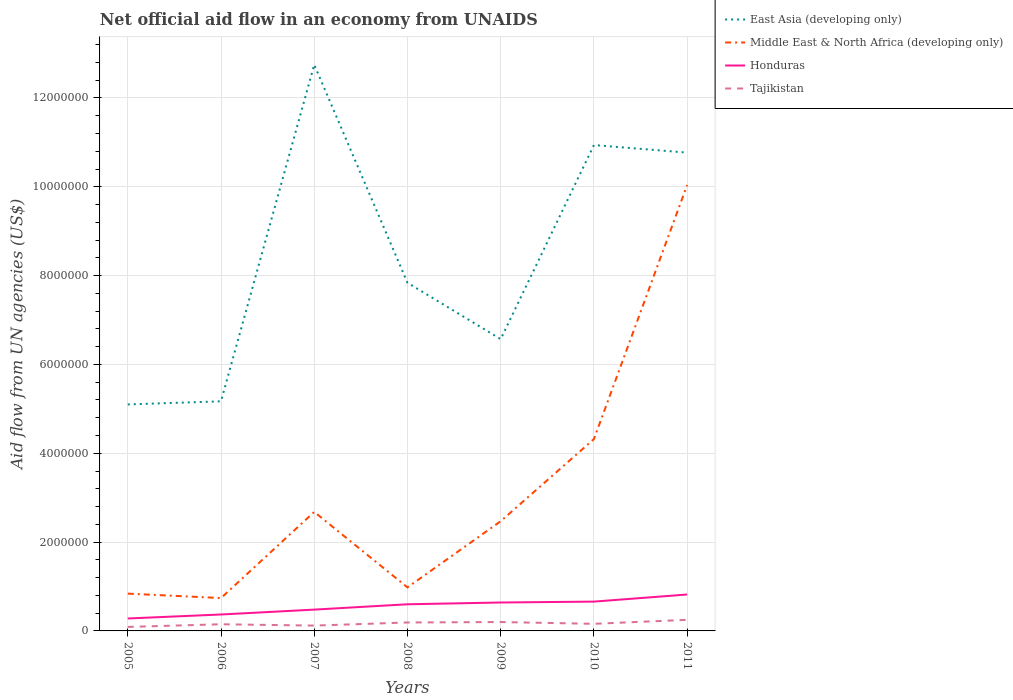How many different coloured lines are there?
Give a very brief answer. 4. Does the line corresponding to Honduras intersect with the line corresponding to Tajikistan?
Your answer should be very brief. No. Across all years, what is the maximum net official aid flow in Middle East & North Africa (developing only)?
Your answer should be compact. 7.40e+05. In which year was the net official aid flow in Tajikistan maximum?
Provide a succinct answer. 2005. What is the total net official aid flow in East Asia (developing only) in the graph?
Make the answer very short. -7.58e+06. What is the difference between the highest and the second highest net official aid flow in Tajikistan?
Offer a terse response. 1.60e+05. Is the net official aid flow in East Asia (developing only) strictly greater than the net official aid flow in Honduras over the years?
Offer a terse response. No. How many lines are there?
Your answer should be very brief. 4. Does the graph contain any zero values?
Make the answer very short. No. Does the graph contain grids?
Offer a very short reply. Yes. How many legend labels are there?
Your answer should be very brief. 4. What is the title of the graph?
Provide a short and direct response. Net official aid flow in an economy from UNAIDS. Does "Algeria" appear as one of the legend labels in the graph?
Offer a terse response. No. What is the label or title of the Y-axis?
Provide a succinct answer. Aid flow from UN agencies (US$). What is the Aid flow from UN agencies (US$) in East Asia (developing only) in 2005?
Ensure brevity in your answer.  5.10e+06. What is the Aid flow from UN agencies (US$) in Middle East & North Africa (developing only) in 2005?
Offer a very short reply. 8.40e+05. What is the Aid flow from UN agencies (US$) in Tajikistan in 2005?
Your response must be concise. 9.00e+04. What is the Aid flow from UN agencies (US$) of East Asia (developing only) in 2006?
Provide a succinct answer. 5.17e+06. What is the Aid flow from UN agencies (US$) of Middle East & North Africa (developing only) in 2006?
Give a very brief answer. 7.40e+05. What is the Aid flow from UN agencies (US$) of Honduras in 2006?
Offer a terse response. 3.70e+05. What is the Aid flow from UN agencies (US$) in Tajikistan in 2006?
Make the answer very short. 1.50e+05. What is the Aid flow from UN agencies (US$) of East Asia (developing only) in 2007?
Ensure brevity in your answer.  1.28e+07. What is the Aid flow from UN agencies (US$) in Middle East & North Africa (developing only) in 2007?
Give a very brief answer. 2.68e+06. What is the Aid flow from UN agencies (US$) of East Asia (developing only) in 2008?
Keep it short and to the point. 7.84e+06. What is the Aid flow from UN agencies (US$) of Middle East & North Africa (developing only) in 2008?
Give a very brief answer. 9.80e+05. What is the Aid flow from UN agencies (US$) in Tajikistan in 2008?
Offer a terse response. 1.90e+05. What is the Aid flow from UN agencies (US$) in East Asia (developing only) in 2009?
Keep it short and to the point. 6.57e+06. What is the Aid flow from UN agencies (US$) in Middle East & North Africa (developing only) in 2009?
Your answer should be very brief. 2.47e+06. What is the Aid flow from UN agencies (US$) in Honduras in 2009?
Provide a short and direct response. 6.40e+05. What is the Aid flow from UN agencies (US$) of East Asia (developing only) in 2010?
Keep it short and to the point. 1.09e+07. What is the Aid flow from UN agencies (US$) in Middle East & North Africa (developing only) in 2010?
Your response must be concise. 4.32e+06. What is the Aid flow from UN agencies (US$) in East Asia (developing only) in 2011?
Provide a short and direct response. 1.08e+07. What is the Aid flow from UN agencies (US$) of Middle East & North Africa (developing only) in 2011?
Your answer should be very brief. 1.00e+07. What is the Aid flow from UN agencies (US$) of Honduras in 2011?
Your answer should be very brief. 8.20e+05. What is the Aid flow from UN agencies (US$) of Tajikistan in 2011?
Offer a terse response. 2.50e+05. Across all years, what is the maximum Aid flow from UN agencies (US$) of East Asia (developing only)?
Your response must be concise. 1.28e+07. Across all years, what is the maximum Aid flow from UN agencies (US$) of Middle East & North Africa (developing only)?
Offer a very short reply. 1.00e+07. Across all years, what is the maximum Aid flow from UN agencies (US$) of Honduras?
Provide a short and direct response. 8.20e+05. Across all years, what is the minimum Aid flow from UN agencies (US$) in East Asia (developing only)?
Ensure brevity in your answer.  5.10e+06. Across all years, what is the minimum Aid flow from UN agencies (US$) in Middle East & North Africa (developing only)?
Your answer should be compact. 7.40e+05. Across all years, what is the minimum Aid flow from UN agencies (US$) in Honduras?
Provide a succinct answer. 2.80e+05. Across all years, what is the minimum Aid flow from UN agencies (US$) of Tajikistan?
Your answer should be very brief. 9.00e+04. What is the total Aid flow from UN agencies (US$) in East Asia (developing only) in the graph?
Provide a short and direct response. 5.91e+07. What is the total Aid flow from UN agencies (US$) of Middle East & North Africa (developing only) in the graph?
Ensure brevity in your answer.  2.21e+07. What is the total Aid flow from UN agencies (US$) in Honduras in the graph?
Your response must be concise. 3.85e+06. What is the total Aid flow from UN agencies (US$) in Tajikistan in the graph?
Ensure brevity in your answer.  1.16e+06. What is the difference between the Aid flow from UN agencies (US$) in Middle East & North Africa (developing only) in 2005 and that in 2006?
Your response must be concise. 1.00e+05. What is the difference between the Aid flow from UN agencies (US$) in East Asia (developing only) in 2005 and that in 2007?
Ensure brevity in your answer.  -7.65e+06. What is the difference between the Aid flow from UN agencies (US$) in Middle East & North Africa (developing only) in 2005 and that in 2007?
Your answer should be very brief. -1.84e+06. What is the difference between the Aid flow from UN agencies (US$) in Honduras in 2005 and that in 2007?
Offer a very short reply. -2.00e+05. What is the difference between the Aid flow from UN agencies (US$) of East Asia (developing only) in 2005 and that in 2008?
Make the answer very short. -2.74e+06. What is the difference between the Aid flow from UN agencies (US$) of Honduras in 2005 and that in 2008?
Provide a succinct answer. -3.20e+05. What is the difference between the Aid flow from UN agencies (US$) of Tajikistan in 2005 and that in 2008?
Offer a terse response. -1.00e+05. What is the difference between the Aid flow from UN agencies (US$) in East Asia (developing only) in 2005 and that in 2009?
Provide a short and direct response. -1.47e+06. What is the difference between the Aid flow from UN agencies (US$) of Middle East & North Africa (developing only) in 2005 and that in 2009?
Provide a succinct answer. -1.63e+06. What is the difference between the Aid flow from UN agencies (US$) of Honduras in 2005 and that in 2009?
Your response must be concise. -3.60e+05. What is the difference between the Aid flow from UN agencies (US$) in East Asia (developing only) in 2005 and that in 2010?
Ensure brevity in your answer.  -5.84e+06. What is the difference between the Aid flow from UN agencies (US$) in Middle East & North Africa (developing only) in 2005 and that in 2010?
Your response must be concise. -3.48e+06. What is the difference between the Aid flow from UN agencies (US$) of Honduras in 2005 and that in 2010?
Provide a succinct answer. -3.80e+05. What is the difference between the Aid flow from UN agencies (US$) of East Asia (developing only) in 2005 and that in 2011?
Your response must be concise. -5.67e+06. What is the difference between the Aid flow from UN agencies (US$) of Middle East & North Africa (developing only) in 2005 and that in 2011?
Keep it short and to the point. -9.20e+06. What is the difference between the Aid flow from UN agencies (US$) in Honduras in 2005 and that in 2011?
Ensure brevity in your answer.  -5.40e+05. What is the difference between the Aid flow from UN agencies (US$) in East Asia (developing only) in 2006 and that in 2007?
Offer a very short reply. -7.58e+06. What is the difference between the Aid flow from UN agencies (US$) in Middle East & North Africa (developing only) in 2006 and that in 2007?
Make the answer very short. -1.94e+06. What is the difference between the Aid flow from UN agencies (US$) in East Asia (developing only) in 2006 and that in 2008?
Offer a very short reply. -2.67e+06. What is the difference between the Aid flow from UN agencies (US$) in Middle East & North Africa (developing only) in 2006 and that in 2008?
Offer a very short reply. -2.40e+05. What is the difference between the Aid flow from UN agencies (US$) of Honduras in 2006 and that in 2008?
Offer a very short reply. -2.30e+05. What is the difference between the Aid flow from UN agencies (US$) in East Asia (developing only) in 2006 and that in 2009?
Ensure brevity in your answer.  -1.40e+06. What is the difference between the Aid flow from UN agencies (US$) of Middle East & North Africa (developing only) in 2006 and that in 2009?
Offer a very short reply. -1.73e+06. What is the difference between the Aid flow from UN agencies (US$) in Honduras in 2006 and that in 2009?
Offer a very short reply. -2.70e+05. What is the difference between the Aid flow from UN agencies (US$) of East Asia (developing only) in 2006 and that in 2010?
Offer a very short reply. -5.77e+06. What is the difference between the Aid flow from UN agencies (US$) of Middle East & North Africa (developing only) in 2006 and that in 2010?
Your response must be concise. -3.58e+06. What is the difference between the Aid flow from UN agencies (US$) of Honduras in 2006 and that in 2010?
Provide a succinct answer. -2.90e+05. What is the difference between the Aid flow from UN agencies (US$) in Tajikistan in 2006 and that in 2010?
Make the answer very short. -10000. What is the difference between the Aid flow from UN agencies (US$) in East Asia (developing only) in 2006 and that in 2011?
Your answer should be compact. -5.60e+06. What is the difference between the Aid flow from UN agencies (US$) of Middle East & North Africa (developing only) in 2006 and that in 2011?
Your answer should be very brief. -9.30e+06. What is the difference between the Aid flow from UN agencies (US$) in Honduras in 2006 and that in 2011?
Ensure brevity in your answer.  -4.50e+05. What is the difference between the Aid flow from UN agencies (US$) of East Asia (developing only) in 2007 and that in 2008?
Keep it short and to the point. 4.91e+06. What is the difference between the Aid flow from UN agencies (US$) in Middle East & North Africa (developing only) in 2007 and that in 2008?
Your answer should be compact. 1.70e+06. What is the difference between the Aid flow from UN agencies (US$) of Honduras in 2007 and that in 2008?
Keep it short and to the point. -1.20e+05. What is the difference between the Aid flow from UN agencies (US$) of East Asia (developing only) in 2007 and that in 2009?
Provide a short and direct response. 6.18e+06. What is the difference between the Aid flow from UN agencies (US$) of Tajikistan in 2007 and that in 2009?
Ensure brevity in your answer.  -8.00e+04. What is the difference between the Aid flow from UN agencies (US$) of East Asia (developing only) in 2007 and that in 2010?
Provide a short and direct response. 1.81e+06. What is the difference between the Aid flow from UN agencies (US$) in Middle East & North Africa (developing only) in 2007 and that in 2010?
Make the answer very short. -1.64e+06. What is the difference between the Aid flow from UN agencies (US$) in East Asia (developing only) in 2007 and that in 2011?
Keep it short and to the point. 1.98e+06. What is the difference between the Aid flow from UN agencies (US$) of Middle East & North Africa (developing only) in 2007 and that in 2011?
Give a very brief answer. -7.36e+06. What is the difference between the Aid flow from UN agencies (US$) in Honduras in 2007 and that in 2011?
Offer a very short reply. -3.40e+05. What is the difference between the Aid flow from UN agencies (US$) in Tajikistan in 2007 and that in 2011?
Your answer should be very brief. -1.30e+05. What is the difference between the Aid flow from UN agencies (US$) in East Asia (developing only) in 2008 and that in 2009?
Offer a terse response. 1.27e+06. What is the difference between the Aid flow from UN agencies (US$) of Middle East & North Africa (developing only) in 2008 and that in 2009?
Provide a succinct answer. -1.49e+06. What is the difference between the Aid flow from UN agencies (US$) of Tajikistan in 2008 and that in 2009?
Offer a very short reply. -10000. What is the difference between the Aid flow from UN agencies (US$) of East Asia (developing only) in 2008 and that in 2010?
Keep it short and to the point. -3.10e+06. What is the difference between the Aid flow from UN agencies (US$) of Middle East & North Africa (developing only) in 2008 and that in 2010?
Keep it short and to the point. -3.34e+06. What is the difference between the Aid flow from UN agencies (US$) of Honduras in 2008 and that in 2010?
Provide a succinct answer. -6.00e+04. What is the difference between the Aid flow from UN agencies (US$) in Tajikistan in 2008 and that in 2010?
Provide a succinct answer. 3.00e+04. What is the difference between the Aid flow from UN agencies (US$) of East Asia (developing only) in 2008 and that in 2011?
Your answer should be compact. -2.93e+06. What is the difference between the Aid flow from UN agencies (US$) of Middle East & North Africa (developing only) in 2008 and that in 2011?
Offer a terse response. -9.06e+06. What is the difference between the Aid flow from UN agencies (US$) of East Asia (developing only) in 2009 and that in 2010?
Ensure brevity in your answer.  -4.37e+06. What is the difference between the Aid flow from UN agencies (US$) of Middle East & North Africa (developing only) in 2009 and that in 2010?
Offer a very short reply. -1.85e+06. What is the difference between the Aid flow from UN agencies (US$) of East Asia (developing only) in 2009 and that in 2011?
Your response must be concise. -4.20e+06. What is the difference between the Aid flow from UN agencies (US$) of Middle East & North Africa (developing only) in 2009 and that in 2011?
Ensure brevity in your answer.  -7.57e+06. What is the difference between the Aid flow from UN agencies (US$) of Tajikistan in 2009 and that in 2011?
Keep it short and to the point. -5.00e+04. What is the difference between the Aid flow from UN agencies (US$) in Middle East & North Africa (developing only) in 2010 and that in 2011?
Give a very brief answer. -5.72e+06. What is the difference between the Aid flow from UN agencies (US$) of Honduras in 2010 and that in 2011?
Keep it short and to the point. -1.60e+05. What is the difference between the Aid flow from UN agencies (US$) of Tajikistan in 2010 and that in 2011?
Give a very brief answer. -9.00e+04. What is the difference between the Aid flow from UN agencies (US$) in East Asia (developing only) in 2005 and the Aid flow from UN agencies (US$) in Middle East & North Africa (developing only) in 2006?
Make the answer very short. 4.36e+06. What is the difference between the Aid flow from UN agencies (US$) of East Asia (developing only) in 2005 and the Aid flow from UN agencies (US$) of Honduras in 2006?
Offer a terse response. 4.73e+06. What is the difference between the Aid flow from UN agencies (US$) in East Asia (developing only) in 2005 and the Aid flow from UN agencies (US$) in Tajikistan in 2006?
Ensure brevity in your answer.  4.95e+06. What is the difference between the Aid flow from UN agencies (US$) of Middle East & North Africa (developing only) in 2005 and the Aid flow from UN agencies (US$) of Honduras in 2006?
Your answer should be compact. 4.70e+05. What is the difference between the Aid flow from UN agencies (US$) in Middle East & North Africa (developing only) in 2005 and the Aid flow from UN agencies (US$) in Tajikistan in 2006?
Provide a succinct answer. 6.90e+05. What is the difference between the Aid flow from UN agencies (US$) of East Asia (developing only) in 2005 and the Aid flow from UN agencies (US$) of Middle East & North Africa (developing only) in 2007?
Provide a succinct answer. 2.42e+06. What is the difference between the Aid flow from UN agencies (US$) of East Asia (developing only) in 2005 and the Aid flow from UN agencies (US$) of Honduras in 2007?
Provide a succinct answer. 4.62e+06. What is the difference between the Aid flow from UN agencies (US$) in East Asia (developing only) in 2005 and the Aid flow from UN agencies (US$) in Tajikistan in 2007?
Provide a short and direct response. 4.98e+06. What is the difference between the Aid flow from UN agencies (US$) in Middle East & North Africa (developing only) in 2005 and the Aid flow from UN agencies (US$) in Honduras in 2007?
Keep it short and to the point. 3.60e+05. What is the difference between the Aid flow from UN agencies (US$) in Middle East & North Africa (developing only) in 2005 and the Aid flow from UN agencies (US$) in Tajikistan in 2007?
Your answer should be compact. 7.20e+05. What is the difference between the Aid flow from UN agencies (US$) in East Asia (developing only) in 2005 and the Aid flow from UN agencies (US$) in Middle East & North Africa (developing only) in 2008?
Provide a succinct answer. 4.12e+06. What is the difference between the Aid flow from UN agencies (US$) in East Asia (developing only) in 2005 and the Aid flow from UN agencies (US$) in Honduras in 2008?
Give a very brief answer. 4.50e+06. What is the difference between the Aid flow from UN agencies (US$) of East Asia (developing only) in 2005 and the Aid flow from UN agencies (US$) of Tajikistan in 2008?
Offer a terse response. 4.91e+06. What is the difference between the Aid flow from UN agencies (US$) in Middle East & North Africa (developing only) in 2005 and the Aid flow from UN agencies (US$) in Tajikistan in 2008?
Keep it short and to the point. 6.50e+05. What is the difference between the Aid flow from UN agencies (US$) of Honduras in 2005 and the Aid flow from UN agencies (US$) of Tajikistan in 2008?
Your response must be concise. 9.00e+04. What is the difference between the Aid flow from UN agencies (US$) in East Asia (developing only) in 2005 and the Aid flow from UN agencies (US$) in Middle East & North Africa (developing only) in 2009?
Give a very brief answer. 2.63e+06. What is the difference between the Aid flow from UN agencies (US$) of East Asia (developing only) in 2005 and the Aid flow from UN agencies (US$) of Honduras in 2009?
Make the answer very short. 4.46e+06. What is the difference between the Aid flow from UN agencies (US$) of East Asia (developing only) in 2005 and the Aid flow from UN agencies (US$) of Tajikistan in 2009?
Provide a short and direct response. 4.90e+06. What is the difference between the Aid flow from UN agencies (US$) of Middle East & North Africa (developing only) in 2005 and the Aid flow from UN agencies (US$) of Honduras in 2009?
Keep it short and to the point. 2.00e+05. What is the difference between the Aid flow from UN agencies (US$) in Middle East & North Africa (developing only) in 2005 and the Aid flow from UN agencies (US$) in Tajikistan in 2009?
Ensure brevity in your answer.  6.40e+05. What is the difference between the Aid flow from UN agencies (US$) in East Asia (developing only) in 2005 and the Aid flow from UN agencies (US$) in Middle East & North Africa (developing only) in 2010?
Provide a succinct answer. 7.80e+05. What is the difference between the Aid flow from UN agencies (US$) in East Asia (developing only) in 2005 and the Aid flow from UN agencies (US$) in Honduras in 2010?
Your answer should be compact. 4.44e+06. What is the difference between the Aid flow from UN agencies (US$) in East Asia (developing only) in 2005 and the Aid flow from UN agencies (US$) in Tajikistan in 2010?
Provide a short and direct response. 4.94e+06. What is the difference between the Aid flow from UN agencies (US$) of Middle East & North Africa (developing only) in 2005 and the Aid flow from UN agencies (US$) of Honduras in 2010?
Keep it short and to the point. 1.80e+05. What is the difference between the Aid flow from UN agencies (US$) in Middle East & North Africa (developing only) in 2005 and the Aid flow from UN agencies (US$) in Tajikistan in 2010?
Your response must be concise. 6.80e+05. What is the difference between the Aid flow from UN agencies (US$) of East Asia (developing only) in 2005 and the Aid flow from UN agencies (US$) of Middle East & North Africa (developing only) in 2011?
Make the answer very short. -4.94e+06. What is the difference between the Aid flow from UN agencies (US$) of East Asia (developing only) in 2005 and the Aid flow from UN agencies (US$) of Honduras in 2011?
Ensure brevity in your answer.  4.28e+06. What is the difference between the Aid flow from UN agencies (US$) in East Asia (developing only) in 2005 and the Aid flow from UN agencies (US$) in Tajikistan in 2011?
Ensure brevity in your answer.  4.85e+06. What is the difference between the Aid flow from UN agencies (US$) in Middle East & North Africa (developing only) in 2005 and the Aid flow from UN agencies (US$) in Tajikistan in 2011?
Your answer should be very brief. 5.90e+05. What is the difference between the Aid flow from UN agencies (US$) in East Asia (developing only) in 2006 and the Aid flow from UN agencies (US$) in Middle East & North Africa (developing only) in 2007?
Provide a succinct answer. 2.49e+06. What is the difference between the Aid flow from UN agencies (US$) in East Asia (developing only) in 2006 and the Aid flow from UN agencies (US$) in Honduras in 2007?
Provide a succinct answer. 4.69e+06. What is the difference between the Aid flow from UN agencies (US$) in East Asia (developing only) in 2006 and the Aid flow from UN agencies (US$) in Tajikistan in 2007?
Provide a short and direct response. 5.05e+06. What is the difference between the Aid flow from UN agencies (US$) of Middle East & North Africa (developing only) in 2006 and the Aid flow from UN agencies (US$) of Honduras in 2007?
Keep it short and to the point. 2.60e+05. What is the difference between the Aid flow from UN agencies (US$) in Middle East & North Africa (developing only) in 2006 and the Aid flow from UN agencies (US$) in Tajikistan in 2007?
Offer a terse response. 6.20e+05. What is the difference between the Aid flow from UN agencies (US$) in East Asia (developing only) in 2006 and the Aid flow from UN agencies (US$) in Middle East & North Africa (developing only) in 2008?
Give a very brief answer. 4.19e+06. What is the difference between the Aid flow from UN agencies (US$) of East Asia (developing only) in 2006 and the Aid flow from UN agencies (US$) of Honduras in 2008?
Offer a terse response. 4.57e+06. What is the difference between the Aid flow from UN agencies (US$) of East Asia (developing only) in 2006 and the Aid flow from UN agencies (US$) of Tajikistan in 2008?
Provide a succinct answer. 4.98e+06. What is the difference between the Aid flow from UN agencies (US$) of East Asia (developing only) in 2006 and the Aid flow from UN agencies (US$) of Middle East & North Africa (developing only) in 2009?
Provide a succinct answer. 2.70e+06. What is the difference between the Aid flow from UN agencies (US$) of East Asia (developing only) in 2006 and the Aid flow from UN agencies (US$) of Honduras in 2009?
Offer a very short reply. 4.53e+06. What is the difference between the Aid flow from UN agencies (US$) of East Asia (developing only) in 2006 and the Aid flow from UN agencies (US$) of Tajikistan in 2009?
Provide a succinct answer. 4.97e+06. What is the difference between the Aid flow from UN agencies (US$) of Middle East & North Africa (developing only) in 2006 and the Aid flow from UN agencies (US$) of Honduras in 2009?
Offer a very short reply. 1.00e+05. What is the difference between the Aid flow from UN agencies (US$) of Middle East & North Africa (developing only) in 2006 and the Aid flow from UN agencies (US$) of Tajikistan in 2009?
Provide a succinct answer. 5.40e+05. What is the difference between the Aid flow from UN agencies (US$) of East Asia (developing only) in 2006 and the Aid flow from UN agencies (US$) of Middle East & North Africa (developing only) in 2010?
Your response must be concise. 8.50e+05. What is the difference between the Aid flow from UN agencies (US$) in East Asia (developing only) in 2006 and the Aid flow from UN agencies (US$) in Honduras in 2010?
Offer a very short reply. 4.51e+06. What is the difference between the Aid flow from UN agencies (US$) in East Asia (developing only) in 2006 and the Aid flow from UN agencies (US$) in Tajikistan in 2010?
Ensure brevity in your answer.  5.01e+06. What is the difference between the Aid flow from UN agencies (US$) in Middle East & North Africa (developing only) in 2006 and the Aid flow from UN agencies (US$) in Tajikistan in 2010?
Provide a short and direct response. 5.80e+05. What is the difference between the Aid flow from UN agencies (US$) of Honduras in 2006 and the Aid flow from UN agencies (US$) of Tajikistan in 2010?
Keep it short and to the point. 2.10e+05. What is the difference between the Aid flow from UN agencies (US$) in East Asia (developing only) in 2006 and the Aid flow from UN agencies (US$) in Middle East & North Africa (developing only) in 2011?
Keep it short and to the point. -4.87e+06. What is the difference between the Aid flow from UN agencies (US$) of East Asia (developing only) in 2006 and the Aid flow from UN agencies (US$) of Honduras in 2011?
Your response must be concise. 4.35e+06. What is the difference between the Aid flow from UN agencies (US$) in East Asia (developing only) in 2006 and the Aid flow from UN agencies (US$) in Tajikistan in 2011?
Provide a succinct answer. 4.92e+06. What is the difference between the Aid flow from UN agencies (US$) of Middle East & North Africa (developing only) in 2006 and the Aid flow from UN agencies (US$) of Tajikistan in 2011?
Ensure brevity in your answer.  4.90e+05. What is the difference between the Aid flow from UN agencies (US$) in East Asia (developing only) in 2007 and the Aid flow from UN agencies (US$) in Middle East & North Africa (developing only) in 2008?
Make the answer very short. 1.18e+07. What is the difference between the Aid flow from UN agencies (US$) of East Asia (developing only) in 2007 and the Aid flow from UN agencies (US$) of Honduras in 2008?
Give a very brief answer. 1.22e+07. What is the difference between the Aid flow from UN agencies (US$) in East Asia (developing only) in 2007 and the Aid flow from UN agencies (US$) in Tajikistan in 2008?
Offer a terse response. 1.26e+07. What is the difference between the Aid flow from UN agencies (US$) of Middle East & North Africa (developing only) in 2007 and the Aid flow from UN agencies (US$) of Honduras in 2008?
Make the answer very short. 2.08e+06. What is the difference between the Aid flow from UN agencies (US$) of Middle East & North Africa (developing only) in 2007 and the Aid flow from UN agencies (US$) of Tajikistan in 2008?
Keep it short and to the point. 2.49e+06. What is the difference between the Aid flow from UN agencies (US$) of East Asia (developing only) in 2007 and the Aid flow from UN agencies (US$) of Middle East & North Africa (developing only) in 2009?
Provide a succinct answer. 1.03e+07. What is the difference between the Aid flow from UN agencies (US$) in East Asia (developing only) in 2007 and the Aid flow from UN agencies (US$) in Honduras in 2009?
Offer a very short reply. 1.21e+07. What is the difference between the Aid flow from UN agencies (US$) of East Asia (developing only) in 2007 and the Aid flow from UN agencies (US$) of Tajikistan in 2009?
Ensure brevity in your answer.  1.26e+07. What is the difference between the Aid flow from UN agencies (US$) of Middle East & North Africa (developing only) in 2007 and the Aid flow from UN agencies (US$) of Honduras in 2009?
Offer a very short reply. 2.04e+06. What is the difference between the Aid flow from UN agencies (US$) in Middle East & North Africa (developing only) in 2007 and the Aid flow from UN agencies (US$) in Tajikistan in 2009?
Ensure brevity in your answer.  2.48e+06. What is the difference between the Aid flow from UN agencies (US$) of Honduras in 2007 and the Aid flow from UN agencies (US$) of Tajikistan in 2009?
Provide a short and direct response. 2.80e+05. What is the difference between the Aid flow from UN agencies (US$) in East Asia (developing only) in 2007 and the Aid flow from UN agencies (US$) in Middle East & North Africa (developing only) in 2010?
Provide a short and direct response. 8.43e+06. What is the difference between the Aid flow from UN agencies (US$) in East Asia (developing only) in 2007 and the Aid flow from UN agencies (US$) in Honduras in 2010?
Provide a short and direct response. 1.21e+07. What is the difference between the Aid flow from UN agencies (US$) in East Asia (developing only) in 2007 and the Aid flow from UN agencies (US$) in Tajikistan in 2010?
Your response must be concise. 1.26e+07. What is the difference between the Aid flow from UN agencies (US$) of Middle East & North Africa (developing only) in 2007 and the Aid flow from UN agencies (US$) of Honduras in 2010?
Keep it short and to the point. 2.02e+06. What is the difference between the Aid flow from UN agencies (US$) of Middle East & North Africa (developing only) in 2007 and the Aid flow from UN agencies (US$) of Tajikistan in 2010?
Make the answer very short. 2.52e+06. What is the difference between the Aid flow from UN agencies (US$) of East Asia (developing only) in 2007 and the Aid flow from UN agencies (US$) of Middle East & North Africa (developing only) in 2011?
Make the answer very short. 2.71e+06. What is the difference between the Aid flow from UN agencies (US$) in East Asia (developing only) in 2007 and the Aid flow from UN agencies (US$) in Honduras in 2011?
Provide a short and direct response. 1.19e+07. What is the difference between the Aid flow from UN agencies (US$) of East Asia (developing only) in 2007 and the Aid flow from UN agencies (US$) of Tajikistan in 2011?
Offer a terse response. 1.25e+07. What is the difference between the Aid flow from UN agencies (US$) in Middle East & North Africa (developing only) in 2007 and the Aid flow from UN agencies (US$) in Honduras in 2011?
Provide a succinct answer. 1.86e+06. What is the difference between the Aid flow from UN agencies (US$) of Middle East & North Africa (developing only) in 2007 and the Aid flow from UN agencies (US$) of Tajikistan in 2011?
Offer a terse response. 2.43e+06. What is the difference between the Aid flow from UN agencies (US$) in Honduras in 2007 and the Aid flow from UN agencies (US$) in Tajikistan in 2011?
Ensure brevity in your answer.  2.30e+05. What is the difference between the Aid flow from UN agencies (US$) in East Asia (developing only) in 2008 and the Aid flow from UN agencies (US$) in Middle East & North Africa (developing only) in 2009?
Your response must be concise. 5.37e+06. What is the difference between the Aid flow from UN agencies (US$) in East Asia (developing only) in 2008 and the Aid flow from UN agencies (US$) in Honduras in 2009?
Offer a very short reply. 7.20e+06. What is the difference between the Aid flow from UN agencies (US$) of East Asia (developing only) in 2008 and the Aid flow from UN agencies (US$) of Tajikistan in 2009?
Your answer should be very brief. 7.64e+06. What is the difference between the Aid flow from UN agencies (US$) in Middle East & North Africa (developing only) in 2008 and the Aid flow from UN agencies (US$) in Tajikistan in 2009?
Your answer should be very brief. 7.80e+05. What is the difference between the Aid flow from UN agencies (US$) of East Asia (developing only) in 2008 and the Aid flow from UN agencies (US$) of Middle East & North Africa (developing only) in 2010?
Make the answer very short. 3.52e+06. What is the difference between the Aid flow from UN agencies (US$) in East Asia (developing only) in 2008 and the Aid flow from UN agencies (US$) in Honduras in 2010?
Provide a succinct answer. 7.18e+06. What is the difference between the Aid flow from UN agencies (US$) in East Asia (developing only) in 2008 and the Aid flow from UN agencies (US$) in Tajikistan in 2010?
Your answer should be compact. 7.68e+06. What is the difference between the Aid flow from UN agencies (US$) of Middle East & North Africa (developing only) in 2008 and the Aid flow from UN agencies (US$) of Tajikistan in 2010?
Give a very brief answer. 8.20e+05. What is the difference between the Aid flow from UN agencies (US$) of Honduras in 2008 and the Aid flow from UN agencies (US$) of Tajikistan in 2010?
Your answer should be very brief. 4.40e+05. What is the difference between the Aid flow from UN agencies (US$) in East Asia (developing only) in 2008 and the Aid flow from UN agencies (US$) in Middle East & North Africa (developing only) in 2011?
Provide a succinct answer. -2.20e+06. What is the difference between the Aid flow from UN agencies (US$) in East Asia (developing only) in 2008 and the Aid flow from UN agencies (US$) in Honduras in 2011?
Provide a short and direct response. 7.02e+06. What is the difference between the Aid flow from UN agencies (US$) in East Asia (developing only) in 2008 and the Aid flow from UN agencies (US$) in Tajikistan in 2011?
Your answer should be very brief. 7.59e+06. What is the difference between the Aid flow from UN agencies (US$) of Middle East & North Africa (developing only) in 2008 and the Aid flow from UN agencies (US$) of Tajikistan in 2011?
Offer a terse response. 7.30e+05. What is the difference between the Aid flow from UN agencies (US$) of East Asia (developing only) in 2009 and the Aid flow from UN agencies (US$) of Middle East & North Africa (developing only) in 2010?
Provide a short and direct response. 2.25e+06. What is the difference between the Aid flow from UN agencies (US$) of East Asia (developing only) in 2009 and the Aid flow from UN agencies (US$) of Honduras in 2010?
Offer a very short reply. 5.91e+06. What is the difference between the Aid flow from UN agencies (US$) in East Asia (developing only) in 2009 and the Aid flow from UN agencies (US$) in Tajikistan in 2010?
Make the answer very short. 6.41e+06. What is the difference between the Aid flow from UN agencies (US$) in Middle East & North Africa (developing only) in 2009 and the Aid flow from UN agencies (US$) in Honduras in 2010?
Your response must be concise. 1.81e+06. What is the difference between the Aid flow from UN agencies (US$) of Middle East & North Africa (developing only) in 2009 and the Aid flow from UN agencies (US$) of Tajikistan in 2010?
Your response must be concise. 2.31e+06. What is the difference between the Aid flow from UN agencies (US$) in Honduras in 2009 and the Aid flow from UN agencies (US$) in Tajikistan in 2010?
Provide a short and direct response. 4.80e+05. What is the difference between the Aid flow from UN agencies (US$) of East Asia (developing only) in 2009 and the Aid flow from UN agencies (US$) of Middle East & North Africa (developing only) in 2011?
Provide a short and direct response. -3.47e+06. What is the difference between the Aid flow from UN agencies (US$) in East Asia (developing only) in 2009 and the Aid flow from UN agencies (US$) in Honduras in 2011?
Provide a short and direct response. 5.75e+06. What is the difference between the Aid flow from UN agencies (US$) in East Asia (developing only) in 2009 and the Aid flow from UN agencies (US$) in Tajikistan in 2011?
Provide a succinct answer. 6.32e+06. What is the difference between the Aid flow from UN agencies (US$) of Middle East & North Africa (developing only) in 2009 and the Aid flow from UN agencies (US$) of Honduras in 2011?
Make the answer very short. 1.65e+06. What is the difference between the Aid flow from UN agencies (US$) in Middle East & North Africa (developing only) in 2009 and the Aid flow from UN agencies (US$) in Tajikistan in 2011?
Give a very brief answer. 2.22e+06. What is the difference between the Aid flow from UN agencies (US$) in Honduras in 2009 and the Aid flow from UN agencies (US$) in Tajikistan in 2011?
Provide a succinct answer. 3.90e+05. What is the difference between the Aid flow from UN agencies (US$) in East Asia (developing only) in 2010 and the Aid flow from UN agencies (US$) in Middle East & North Africa (developing only) in 2011?
Make the answer very short. 9.00e+05. What is the difference between the Aid flow from UN agencies (US$) of East Asia (developing only) in 2010 and the Aid flow from UN agencies (US$) of Honduras in 2011?
Keep it short and to the point. 1.01e+07. What is the difference between the Aid flow from UN agencies (US$) in East Asia (developing only) in 2010 and the Aid flow from UN agencies (US$) in Tajikistan in 2011?
Provide a short and direct response. 1.07e+07. What is the difference between the Aid flow from UN agencies (US$) of Middle East & North Africa (developing only) in 2010 and the Aid flow from UN agencies (US$) of Honduras in 2011?
Give a very brief answer. 3.50e+06. What is the difference between the Aid flow from UN agencies (US$) of Middle East & North Africa (developing only) in 2010 and the Aid flow from UN agencies (US$) of Tajikistan in 2011?
Provide a short and direct response. 4.07e+06. What is the average Aid flow from UN agencies (US$) in East Asia (developing only) per year?
Ensure brevity in your answer.  8.45e+06. What is the average Aid flow from UN agencies (US$) in Middle East & North Africa (developing only) per year?
Offer a terse response. 3.15e+06. What is the average Aid flow from UN agencies (US$) in Tajikistan per year?
Make the answer very short. 1.66e+05. In the year 2005, what is the difference between the Aid flow from UN agencies (US$) of East Asia (developing only) and Aid flow from UN agencies (US$) of Middle East & North Africa (developing only)?
Provide a short and direct response. 4.26e+06. In the year 2005, what is the difference between the Aid flow from UN agencies (US$) of East Asia (developing only) and Aid flow from UN agencies (US$) of Honduras?
Ensure brevity in your answer.  4.82e+06. In the year 2005, what is the difference between the Aid flow from UN agencies (US$) in East Asia (developing only) and Aid flow from UN agencies (US$) in Tajikistan?
Your answer should be very brief. 5.01e+06. In the year 2005, what is the difference between the Aid flow from UN agencies (US$) of Middle East & North Africa (developing only) and Aid flow from UN agencies (US$) of Honduras?
Your response must be concise. 5.60e+05. In the year 2005, what is the difference between the Aid flow from UN agencies (US$) in Middle East & North Africa (developing only) and Aid flow from UN agencies (US$) in Tajikistan?
Provide a short and direct response. 7.50e+05. In the year 2006, what is the difference between the Aid flow from UN agencies (US$) of East Asia (developing only) and Aid flow from UN agencies (US$) of Middle East & North Africa (developing only)?
Make the answer very short. 4.43e+06. In the year 2006, what is the difference between the Aid flow from UN agencies (US$) in East Asia (developing only) and Aid flow from UN agencies (US$) in Honduras?
Offer a terse response. 4.80e+06. In the year 2006, what is the difference between the Aid flow from UN agencies (US$) in East Asia (developing only) and Aid flow from UN agencies (US$) in Tajikistan?
Keep it short and to the point. 5.02e+06. In the year 2006, what is the difference between the Aid flow from UN agencies (US$) in Middle East & North Africa (developing only) and Aid flow from UN agencies (US$) in Honduras?
Make the answer very short. 3.70e+05. In the year 2006, what is the difference between the Aid flow from UN agencies (US$) of Middle East & North Africa (developing only) and Aid flow from UN agencies (US$) of Tajikistan?
Offer a very short reply. 5.90e+05. In the year 2006, what is the difference between the Aid flow from UN agencies (US$) in Honduras and Aid flow from UN agencies (US$) in Tajikistan?
Your response must be concise. 2.20e+05. In the year 2007, what is the difference between the Aid flow from UN agencies (US$) in East Asia (developing only) and Aid flow from UN agencies (US$) in Middle East & North Africa (developing only)?
Your response must be concise. 1.01e+07. In the year 2007, what is the difference between the Aid flow from UN agencies (US$) of East Asia (developing only) and Aid flow from UN agencies (US$) of Honduras?
Provide a succinct answer. 1.23e+07. In the year 2007, what is the difference between the Aid flow from UN agencies (US$) in East Asia (developing only) and Aid flow from UN agencies (US$) in Tajikistan?
Provide a succinct answer. 1.26e+07. In the year 2007, what is the difference between the Aid flow from UN agencies (US$) in Middle East & North Africa (developing only) and Aid flow from UN agencies (US$) in Honduras?
Give a very brief answer. 2.20e+06. In the year 2007, what is the difference between the Aid flow from UN agencies (US$) in Middle East & North Africa (developing only) and Aid flow from UN agencies (US$) in Tajikistan?
Your answer should be very brief. 2.56e+06. In the year 2007, what is the difference between the Aid flow from UN agencies (US$) of Honduras and Aid flow from UN agencies (US$) of Tajikistan?
Your answer should be compact. 3.60e+05. In the year 2008, what is the difference between the Aid flow from UN agencies (US$) in East Asia (developing only) and Aid flow from UN agencies (US$) in Middle East & North Africa (developing only)?
Offer a very short reply. 6.86e+06. In the year 2008, what is the difference between the Aid flow from UN agencies (US$) in East Asia (developing only) and Aid flow from UN agencies (US$) in Honduras?
Make the answer very short. 7.24e+06. In the year 2008, what is the difference between the Aid flow from UN agencies (US$) in East Asia (developing only) and Aid flow from UN agencies (US$) in Tajikistan?
Make the answer very short. 7.65e+06. In the year 2008, what is the difference between the Aid flow from UN agencies (US$) in Middle East & North Africa (developing only) and Aid flow from UN agencies (US$) in Tajikistan?
Keep it short and to the point. 7.90e+05. In the year 2008, what is the difference between the Aid flow from UN agencies (US$) in Honduras and Aid flow from UN agencies (US$) in Tajikistan?
Provide a short and direct response. 4.10e+05. In the year 2009, what is the difference between the Aid flow from UN agencies (US$) in East Asia (developing only) and Aid flow from UN agencies (US$) in Middle East & North Africa (developing only)?
Offer a very short reply. 4.10e+06. In the year 2009, what is the difference between the Aid flow from UN agencies (US$) of East Asia (developing only) and Aid flow from UN agencies (US$) of Honduras?
Provide a short and direct response. 5.93e+06. In the year 2009, what is the difference between the Aid flow from UN agencies (US$) of East Asia (developing only) and Aid flow from UN agencies (US$) of Tajikistan?
Your answer should be very brief. 6.37e+06. In the year 2009, what is the difference between the Aid flow from UN agencies (US$) of Middle East & North Africa (developing only) and Aid flow from UN agencies (US$) of Honduras?
Give a very brief answer. 1.83e+06. In the year 2009, what is the difference between the Aid flow from UN agencies (US$) of Middle East & North Africa (developing only) and Aid flow from UN agencies (US$) of Tajikistan?
Your answer should be very brief. 2.27e+06. In the year 2010, what is the difference between the Aid flow from UN agencies (US$) of East Asia (developing only) and Aid flow from UN agencies (US$) of Middle East & North Africa (developing only)?
Give a very brief answer. 6.62e+06. In the year 2010, what is the difference between the Aid flow from UN agencies (US$) of East Asia (developing only) and Aid flow from UN agencies (US$) of Honduras?
Your response must be concise. 1.03e+07. In the year 2010, what is the difference between the Aid flow from UN agencies (US$) in East Asia (developing only) and Aid flow from UN agencies (US$) in Tajikistan?
Keep it short and to the point. 1.08e+07. In the year 2010, what is the difference between the Aid flow from UN agencies (US$) in Middle East & North Africa (developing only) and Aid flow from UN agencies (US$) in Honduras?
Your answer should be very brief. 3.66e+06. In the year 2010, what is the difference between the Aid flow from UN agencies (US$) of Middle East & North Africa (developing only) and Aid flow from UN agencies (US$) of Tajikistan?
Your answer should be compact. 4.16e+06. In the year 2010, what is the difference between the Aid flow from UN agencies (US$) in Honduras and Aid flow from UN agencies (US$) in Tajikistan?
Offer a very short reply. 5.00e+05. In the year 2011, what is the difference between the Aid flow from UN agencies (US$) in East Asia (developing only) and Aid flow from UN agencies (US$) in Middle East & North Africa (developing only)?
Your answer should be compact. 7.30e+05. In the year 2011, what is the difference between the Aid flow from UN agencies (US$) in East Asia (developing only) and Aid flow from UN agencies (US$) in Honduras?
Offer a very short reply. 9.95e+06. In the year 2011, what is the difference between the Aid flow from UN agencies (US$) in East Asia (developing only) and Aid flow from UN agencies (US$) in Tajikistan?
Offer a terse response. 1.05e+07. In the year 2011, what is the difference between the Aid flow from UN agencies (US$) in Middle East & North Africa (developing only) and Aid flow from UN agencies (US$) in Honduras?
Offer a very short reply. 9.22e+06. In the year 2011, what is the difference between the Aid flow from UN agencies (US$) of Middle East & North Africa (developing only) and Aid flow from UN agencies (US$) of Tajikistan?
Your answer should be very brief. 9.79e+06. In the year 2011, what is the difference between the Aid flow from UN agencies (US$) in Honduras and Aid flow from UN agencies (US$) in Tajikistan?
Your answer should be compact. 5.70e+05. What is the ratio of the Aid flow from UN agencies (US$) in East Asia (developing only) in 2005 to that in 2006?
Your response must be concise. 0.99. What is the ratio of the Aid flow from UN agencies (US$) of Middle East & North Africa (developing only) in 2005 to that in 2006?
Keep it short and to the point. 1.14. What is the ratio of the Aid flow from UN agencies (US$) of Honduras in 2005 to that in 2006?
Your answer should be compact. 0.76. What is the ratio of the Aid flow from UN agencies (US$) of Middle East & North Africa (developing only) in 2005 to that in 2007?
Your response must be concise. 0.31. What is the ratio of the Aid flow from UN agencies (US$) in Honduras in 2005 to that in 2007?
Offer a very short reply. 0.58. What is the ratio of the Aid flow from UN agencies (US$) in Tajikistan in 2005 to that in 2007?
Your answer should be compact. 0.75. What is the ratio of the Aid flow from UN agencies (US$) of East Asia (developing only) in 2005 to that in 2008?
Keep it short and to the point. 0.65. What is the ratio of the Aid flow from UN agencies (US$) of Middle East & North Africa (developing only) in 2005 to that in 2008?
Keep it short and to the point. 0.86. What is the ratio of the Aid flow from UN agencies (US$) of Honduras in 2005 to that in 2008?
Provide a short and direct response. 0.47. What is the ratio of the Aid flow from UN agencies (US$) in Tajikistan in 2005 to that in 2008?
Give a very brief answer. 0.47. What is the ratio of the Aid flow from UN agencies (US$) in East Asia (developing only) in 2005 to that in 2009?
Keep it short and to the point. 0.78. What is the ratio of the Aid flow from UN agencies (US$) of Middle East & North Africa (developing only) in 2005 to that in 2009?
Make the answer very short. 0.34. What is the ratio of the Aid flow from UN agencies (US$) in Honduras in 2005 to that in 2009?
Make the answer very short. 0.44. What is the ratio of the Aid flow from UN agencies (US$) of Tajikistan in 2005 to that in 2009?
Offer a terse response. 0.45. What is the ratio of the Aid flow from UN agencies (US$) in East Asia (developing only) in 2005 to that in 2010?
Provide a short and direct response. 0.47. What is the ratio of the Aid flow from UN agencies (US$) in Middle East & North Africa (developing only) in 2005 to that in 2010?
Your answer should be compact. 0.19. What is the ratio of the Aid flow from UN agencies (US$) of Honduras in 2005 to that in 2010?
Give a very brief answer. 0.42. What is the ratio of the Aid flow from UN agencies (US$) in Tajikistan in 2005 to that in 2010?
Provide a succinct answer. 0.56. What is the ratio of the Aid flow from UN agencies (US$) in East Asia (developing only) in 2005 to that in 2011?
Your response must be concise. 0.47. What is the ratio of the Aid flow from UN agencies (US$) in Middle East & North Africa (developing only) in 2005 to that in 2011?
Your answer should be compact. 0.08. What is the ratio of the Aid flow from UN agencies (US$) in Honduras in 2005 to that in 2011?
Your answer should be compact. 0.34. What is the ratio of the Aid flow from UN agencies (US$) in Tajikistan in 2005 to that in 2011?
Provide a short and direct response. 0.36. What is the ratio of the Aid flow from UN agencies (US$) in East Asia (developing only) in 2006 to that in 2007?
Your answer should be very brief. 0.41. What is the ratio of the Aid flow from UN agencies (US$) in Middle East & North Africa (developing only) in 2006 to that in 2007?
Offer a very short reply. 0.28. What is the ratio of the Aid flow from UN agencies (US$) in Honduras in 2006 to that in 2007?
Give a very brief answer. 0.77. What is the ratio of the Aid flow from UN agencies (US$) in East Asia (developing only) in 2006 to that in 2008?
Make the answer very short. 0.66. What is the ratio of the Aid flow from UN agencies (US$) of Middle East & North Africa (developing only) in 2006 to that in 2008?
Offer a very short reply. 0.76. What is the ratio of the Aid flow from UN agencies (US$) in Honduras in 2006 to that in 2008?
Provide a succinct answer. 0.62. What is the ratio of the Aid flow from UN agencies (US$) of Tajikistan in 2006 to that in 2008?
Your response must be concise. 0.79. What is the ratio of the Aid flow from UN agencies (US$) of East Asia (developing only) in 2006 to that in 2009?
Ensure brevity in your answer.  0.79. What is the ratio of the Aid flow from UN agencies (US$) in Middle East & North Africa (developing only) in 2006 to that in 2009?
Offer a terse response. 0.3. What is the ratio of the Aid flow from UN agencies (US$) in Honduras in 2006 to that in 2009?
Provide a succinct answer. 0.58. What is the ratio of the Aid flow from UN agencies (US$) of East Asia (developing only) in 2006 to that in 2010?
Provide a succinct answer. 0.47. What is the ratio of the Aid flow from UN agencies (US$) in Middle East & North Africa (developing only) in 2006 to that in 2010?
Your response must be concise. 0.17. What is the ratio of the Aid flow from UN agencies (US$) of Honduras in 2006 to that in 2010?
Your response must be concise. 0.56. What is the ratio of the Aid flow from UN agencies (US$) in East Asia (developing only) in 2006 to that in 2011?
Provide a short and direct response. 0.48. What is the ratio of the Aid flow from UN agencies (US$) in Middle East & North Africa (developing only) in 2006 to that in 2011?
Your answer should be compact. 0.07. What is the ratio of the Aid flow from UN agencies (US$) of Honduras in 2006 to that in 2011?
Give a very brief answer. 0.45. What is the ratio of the Aid flow from UN agencies (US$) in East Asia (developing only) in 2007 to that in 2008?
Your answer should be very brief. 1.63. What is the ratio of the Aid flow from UN agencies (US$) in Middle East & North Africa (developing only) in 2007 to that in 2008?
Offer a terse response. 2.73. What is the ratio of the Aid flow from UN agencies (US$) in Tajikistan in 2007 to that in 2008?
Your answer should be very brief. 0.63. What is the ratio of the Aid flow from UN agencies (US$) in East Asia (developing only) in 2007 to that in 2009?
Give a very brief answer. 1.94. What is the ratio of the Aid flow from UN agencies (US$) of Middle East & North Africa (developing only) in 2007 to that in 2009?
Offer a very short reply. 1.08. What is the ratio of the Aid flow from UN agencies (US$) of East Asia (developing only) in 2007 to that in 2010?
Offer a very short reply. 1.17. What is the ratio of the Aid flow from UN agencies (US$) of Middle East & North Africa (developing only) in 2007 to that in 2010?
Your answer should be very brief. 0.62. What is the ratio of the Aid flow from UN agencies (US$) in Honduras in 2007 to that in 2010?
Provide a short and direct response. 0.73. What is the ratio of the Aid flow from UN agencies (US$) of East Asia (developing only) in 2007 to that in 2011?
Your answer should be very brief. 1.18. What is the ratio of the Aid flow from UN agencies (US$) in Middle East & North Africa (developing only) in 2007 to that in 2011?
Your answer should be compact. 0.27. What is the ratio of the Aid flow from UN agencies (US$) in Honduras in 2007 to that in 2011?
Ensure brevity in your answer.  0.59. What is the ratio of the Aid flow from UN agencies (US$) of Tajikistan in 2007 to that in 2011?
Your response must be concise. 0.48. What is the ratio of the Aid flow from UN agencies (US$) in East Asia (developing only) in 2008 to that in 2009?
Your answer should be compact. 1.19. What is the ratio of the Aid flow from UN agencies (US$) in Middle East & North Africa (developing only) in 2008 to that in 2009?
Offer a terse response. 0.4. What is the ratio of the Aid flow from UN agencies (US$) of Tajikistan in 2008 to that in 2009?
Your answer should be very brief. 0.95. What is the ratio of the Aid flow from UN agencies (US$) in East Asia (developing only) in 2008 to that in 2010?
Provide a short and direct response. 0.72. What is the ratio of the Aid flow from UN agencies (US$) in Middle East & North Africa (developing only) in 2008 to that in 2010?
Offer a terse response. 0.23. What is the ratio of the Aid flow from UN agencies (US$) in Tajikistan in 2008 to that in 2010?
Ensure brevity in your answer.  1.19. What is the ratio of the Aid flow from UN agencies (US$) in East Asia (developing only) in 2008 to that in 2011?
Your answer should be compact. 0.73. What is the ratio of the Aid flow from UN agencies (US$) of Middle East & North Africa (developing only) in 2008 to that in 2011?
Give a very brief answer. 0.1. What is the ratio of the Aid flow from UN agencies (US$) in Honduras in 2008 to that in 2011?
Offer a very short reply. 0.73. What is the ratio of the Aid flow from UN agencies (US$) in Tajikistan in 2008 to that in 2011?
Offer a very short reply. 0.76. What is the ratio of the Aid flow from UN agencies (US$) of East Asia (developing only) in 2009 to that in 2010?
Keep it short and to the point. 0.6. What is the ratio of the Aid flow from UN agencies (US$) of Middle East & North Africa (developing only) in 2009 to that in 2010?
Provide a succinct answer. 0.57. What is the ratio of the Aid flow from UN agencies (US$) of Honduras in 2009 to that in 2010?
Ensure brevity in your answer.  0.97. What is the ratio of the Aid flow from UN agencies (US$) in East Asia (developing only) in 2009 to that in 2011?
Keep it short and to the point. 0.61. What is the ratio of the Aid flow from UN agencies (US$) in Middle East & North Africa (developing only) in 2009 to that in 2011?
Keep it short and to the point. 0.25. What is the ratio of the Aid flow from UN agencies (US$) of Honduras in 2009 to that in 2011?
Your response must be concise. 0.78. What is the ratio of the Aid flow from UN agencies (US$) in Tajikistan in 2009 to that in 2011?
Your response must be concise. 0.8. What is the ratio of the Aid flow from UN agencies (US$) of East Asia (developing only) in 2010 to that in 2011?
Offer a very short reply. 1.02. What is the ratio of the Aid flow from UN agencies (US$) of Middle East & North Africa (developing only) in 2010 to that in 2011?
Offer a terse response. 0.43. What is the ratio of the Aid flow from UN agencies (US$) in Honduras in 2010 to that in 2011?
Your response must be concise. 0.8. What is the ratio of the Aid flow from UN agencies (US$) of Tajikistan in 2010 to that in 2011?
Provide a succinct answer. 0.64. What is the difference between the highest and the second highest Aid flow from UN agencies (US$) in East Asia (developing only)?
Your answer should be very brief. 1.81e+06. What is the difference between the highest and the second highest Aid flow from UN agencies (US$) of Middle East & North Africa (developing only)?
Make the answer very short. 5.72e+06. What is the difference between the highest and the second highest Aid flow from UN agencies (US$) of Tajikistan?
Your answer should be very brief. 5.00e+04. What is the difference between the highest and the lowest Aid flow from UN agencies (US$) in East Asia (developing only)?
Offer a terse response. 7.65e+06. What is the difference between the highest and the lowest Aid flow from UN agencies (US$) of Middle East & North Africa (developing only)?
Ensure brevity in your answer.  9.30e+06. What is the difference between the highest and the lowest Aid flow from UN agencies (US$) in Honduras?
Keep it short and to the point. 5.40e+05. 